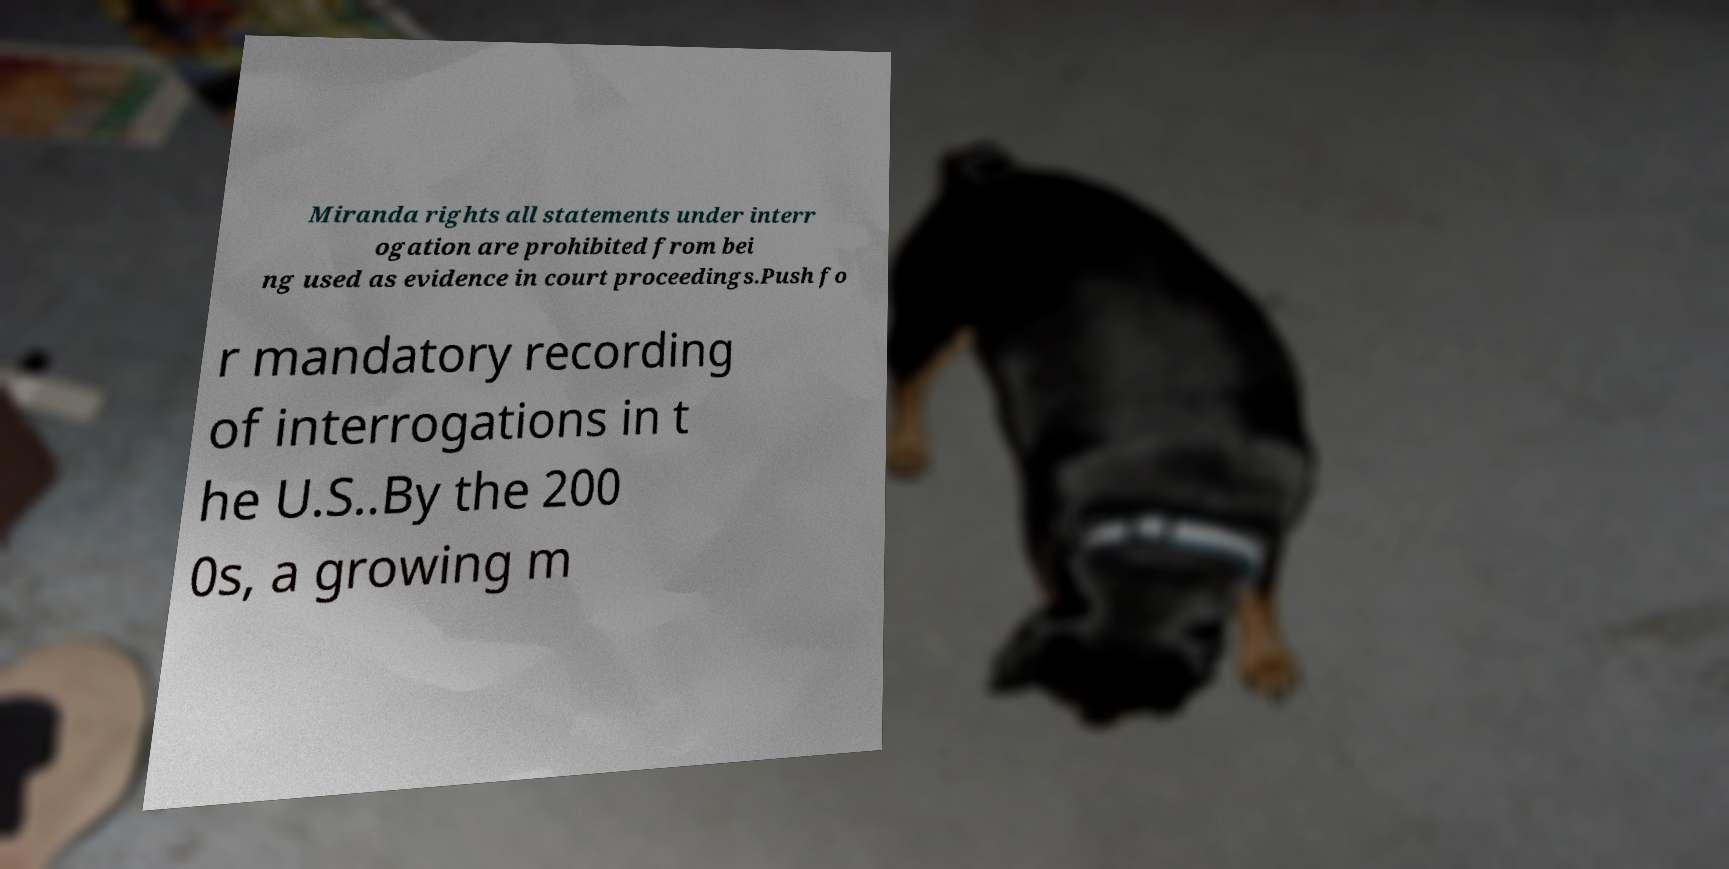Can you accurately transcribe the text from the provided image for me? Miranda rights all statements under interr ogation are prohibited from bei ng used as evidence in court proceedings.Push fo r mandatory recording of interrogations in t he U.S..By the 200 0s, a growing m 